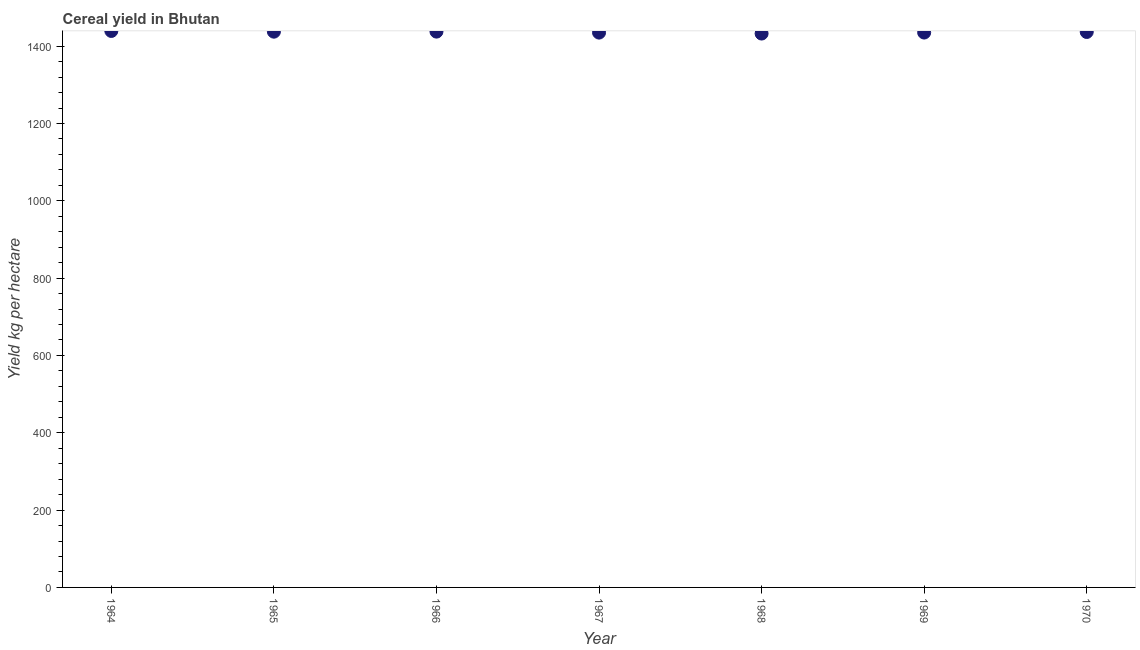What is the cereal yield in 1964?
Keep it short and to the point. 1439.37. Across all years, what is the maximum cereal yield?
Provide a succinct answer. 1439.37. Across all years, what is the minimum cereal yield?
Your response must be concise. 1432.66. In which year was the cereal yield maximum?
Ensure brevity in your answer.  1964. In which year was the cereal yield minimum?
Your answer should be very brief. 1968. What is the sum of the cereal yield?
Offer a very short reply. 1.01e+04. What is the difference between the cereal yield in 1969 and 1970?
Keep it short and to the point. -1.48. What is the average cereal yield per year?
Your response must be concise. 1436.32. What is the median cereal yield?
Keep it short and to the point. 1436.72. In how many years, is the cereal yield greater than 1200 kg per hectare?
Provide a succinct answer. 7. What is the ratio of the cereal yield in 1965 to that in 1969?
Your answer should be compact. 1. Is the cereal yield in 1965 less than that in 1966?
Make the answer very short. Yes. What is the difference between the highest and the second highest cereal yield?
Give a very brief answer. 1.71. Is the sum of the cereal yield in 1966 and 1967 greater than the maximum cereal yield across all years?
Keep it short and to the point. Yes. What is the difference between the highest and the lowest cereal yield?
Provide a succinct answer. 6.71. How many dotlines are there?
Give a very brief answer. 1. What is the difference between two consecutive major ticks on the Y-axis?
Keep it short and to the point. 200. Are the values on the major ticks of Y-axis written in scientific E-notation?
Make the answer very short. No. Does the graph contain grids?
Keep it short and to the point. No. What is the title of the graph?
Offer a very short reply. Cereal yield in Bhutan. What is the label or title of the X-axis?
Your answer should be compact. Year. What is the label or title of the Y-axis?
Provide a succinct answer. Yield kg per hectare. What is the Yield kg per hectare in 1964?
Your answer should be compact. 1439.37. What is the Yield kg per hectare in 1965?
Provide a succinct answer. 1437.51. What is the Yield kg per hectare in 1966?
Your answer should be compact. 1437.66. What is the Yield kg per hectare in 1967?
Your response must be concise. 1435.11. What is the Yield kg per hectare in 1968?
Make the answer very short. 1432.66. What is the Yield kg per hectare in 1969?
Your answer should be compact. 1435.24. What is the Yield kg per hectare in 1970?
Ensure brevity in your answer.  1436.72. What is the difference between the Yield kg per hectare in 1964 and 1965?
Offer a terse response. 1.86. What is the difference between the Yield kg per hectare in 1964 and 1966?
Offer a terse response. 1.71. What is the difference between the Yield kg per hectare in 1964 and 1967?
Provide a succinct answer. 4.26. What is the difference between the Yield kg per hectare in 1964 and 1968?
Give a very brief answer. 6.71. What is the difference between the Yield kg per hectare in 1964 and 1969?
Provide a succinct answer. 4.13. What is the difference between the Yield kg per hectare in 1964 and 1970?
Offer a terse response. 2.65. What is the difference between the Yield kg per hectare in 1965 and 1966?
Keep it short and to the point. -0.15. What is the difference between the Yield kg per hectare in 1965 and 1967?
Offer a terse response. 2.4. What is the difference between the Yield kg per hectare in 1965 and 1968?
Your response must be concise. 4.85. What is the difference between the Yield kg per hectare in 1965 and 1969?
Make the answer very short. 2.27. What is the difference between the Yield kg per hectare in 1965 and 1970?
Make the answer very short. 0.79. What is the difference between the Yield kg per hectare in 1966 and 1967?
Ensure brevity in your answer.  2.55. What is the difference between the Yield kg per hectare in 1966 and 1968?
Your response must be concise. 5. What is the difference between the Yield kg per hectare in 1966 and 1969?
Offer a very short reply. 2.42. What is the difference between the Yield kg per hectare in 1966 and 1970?
Provide a succinct answer. 0.94. What is the difference between the Yield kg per hectare in 1967 and 1968?
Make the answer very short. 2.45. What is the difference between the Yield kg per hectare in 1967 and 1969?
Keep it short and to the point. -0.13. What is the difference between the Yield kg per hectare in 1967 and 1970?
Provide a succinct answer. -1.61. What is the difference between the Yield kg per hectare in 1968 and 1969?
Give a very brief answer. -2.58. What is the difference between the Yield kg per hectare in 1968 and 1970?
Make the answer very short. -4.06. What is the difference between the Yield kg per hectare in 1969 and 1970?
Your answer should be compact. -1.48. What is the ratio of the Yield kg per hectare in 1964 to that in 1965?
Offer a very short reply. 1. What is the ratio of the Yield kg per hectare in 1964 to that in 1967?
Make the answer very short. 1. What is the ratio of the Yield kg per hectare in 1964 to that in 1969?
Make the answer very short. 1. What is the ratio of the Yield kg per hectare in 1965 to that in 1970?
Your response must be concise. 1. What is the ratio of the Yield kg per hectare in 1966 to that in 1968?
Provide a short and direct response. 1. What is the ratio of the Yield kg per hectare in 1967 to that in 1968?
Make the answer very short. 1. What is the ratio of the Yield kg per hectare in 1967 to that in 1969?
Keep it short and to the point. 1. What is the ratio of the Yield kg per hectare in 1968 to that in 1969?
Offer a terse response. 1. What is the ratio of the Yield kg per hectare in 1969 to that in 1970?
Your answer should be very brief. 1. 